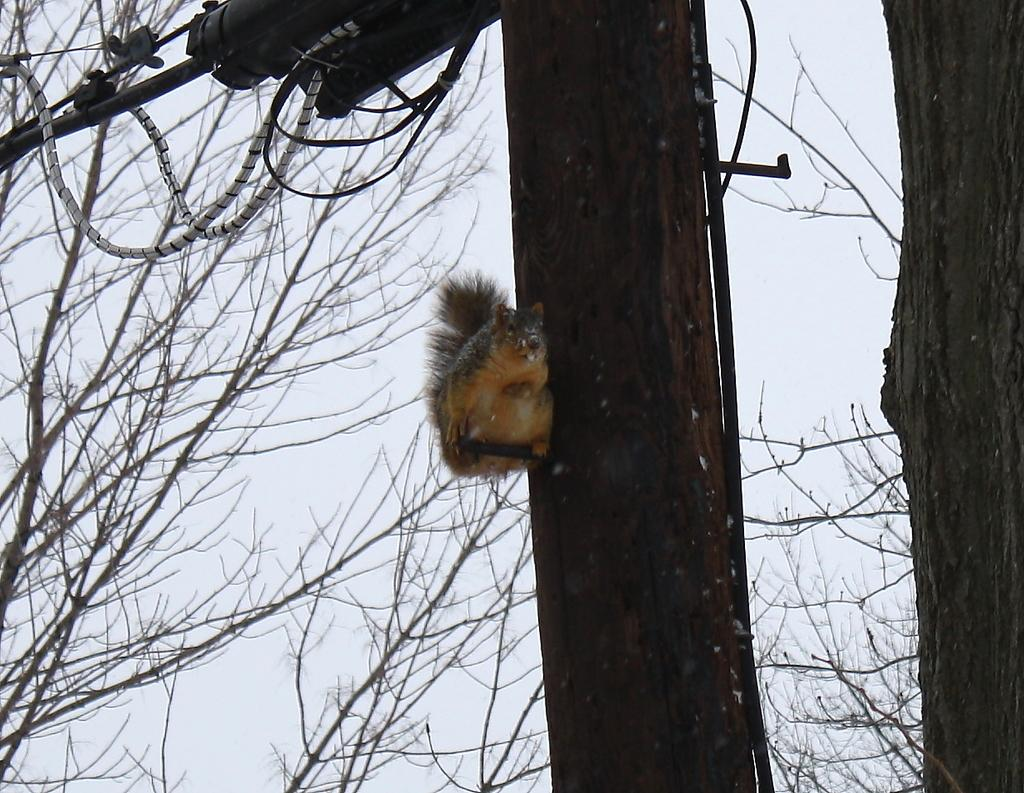What is the main subject of the image? There is an animal on a tree in the image. Can you describe the position of the animal in the image? The animal is on a tree in the image. Is there anything else present in the image besides the animal? Yes, there is an object in front of the animal in the image. What type of bun can be seen in the image? There is no bun present in the image; it features an animal on a tree and an object in front of it. How much waste is visible in the image? There is no waste visible in the image; it only shows an animal on a tree and an object in front of it. 